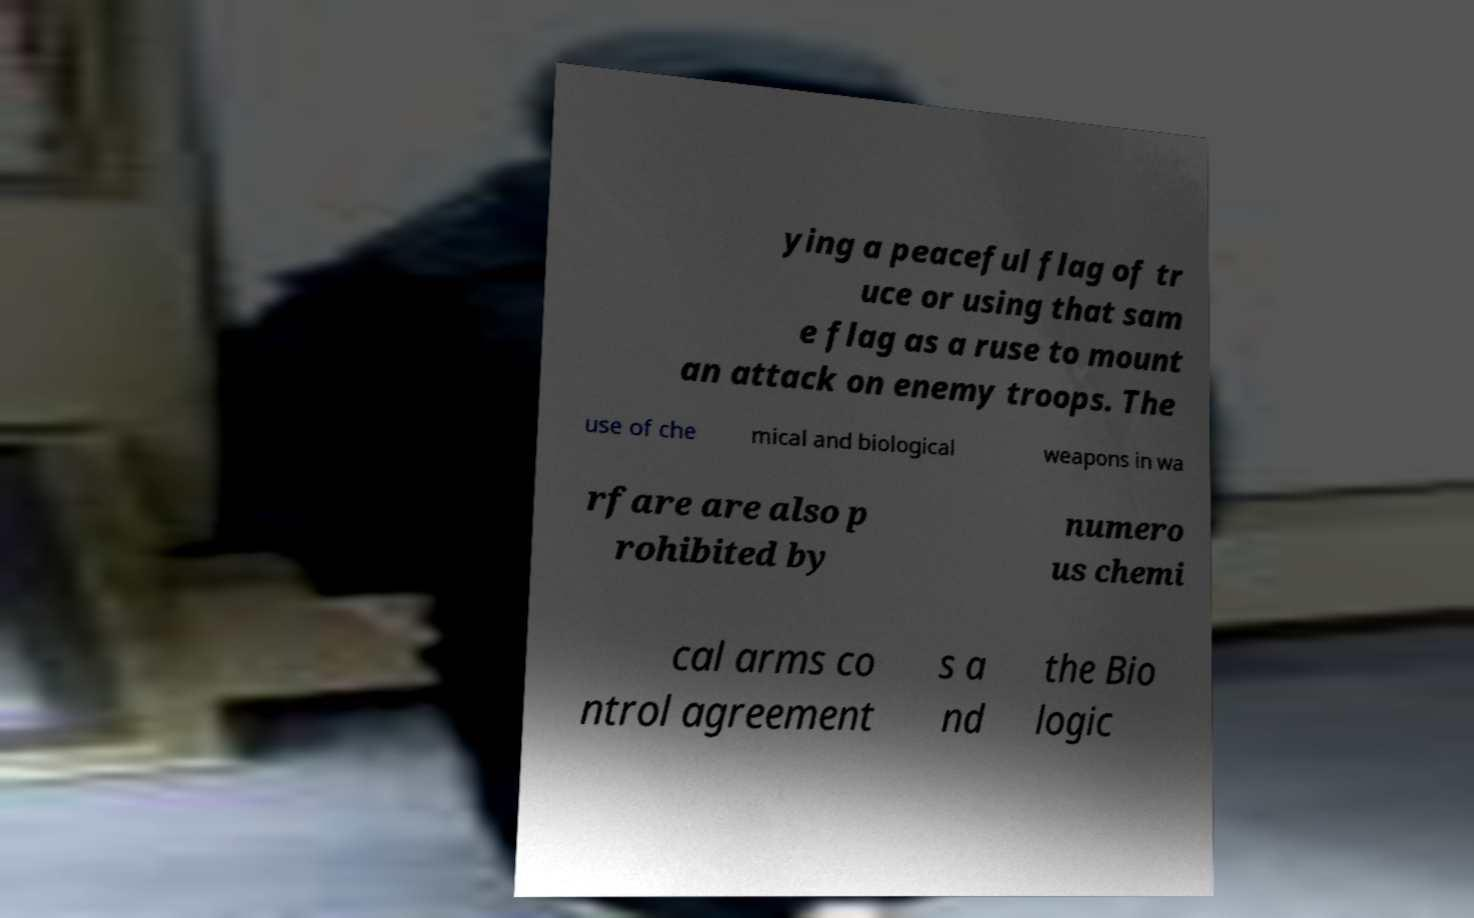Please identify and transcribe the text found in this image. ying a peaceful flag of tr uce or using that sam e flag as a ruse to mount an attack on enemy troops. The use of che mical and biological weapons in wa rfare are also p rohibited by numero us chemi cal arms co ntrol agreement s a nd the Bio logic 